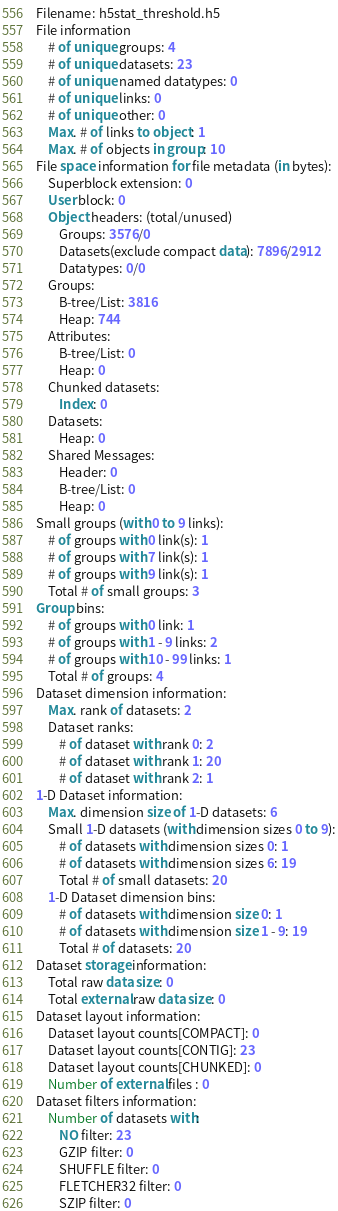<code> <loc_0><loc_0><loc_500><loc_500><_SQL_>Filename: h5stat_threshold.h5
File information
	# of unique groups: 4
	# of unique datasets: 23
	# of unique named datatypes: 0
	# of unique links: 0
	# of unique other: 0
	Max. # of links to object: 1
	Max. # of objects in group: 10
File space information for file metadata (in bytes):
	Superblock extension: 0
	User block: 0
	Object headers: (total/unused)
		Groups: 3576/0
		Datasets(exclude compact data): 7896/2912
		Datatypes: 0/0
	Groups:
		B-tree/List: 3816
		Heap: 744
	Attributes:
		B-tree/List: 0
		Heap: 0
	Chunked datasets:
		Index: 0
	Datasets:
		Heap: 0
	Shared Messages:
		Header: 0
		B-tree/List: 0
		Heap: 0
Small groups (with 0 to 9 links):
	# of groups with 0 link(s): 1
	# of groups with 7 link(s): 1
	# of groups with 9 link(s): 1
	Total # of small groups: 3
Group bins:
	# of groups with 0 link: 1
	# of groups with 1 - 9 links: 2
	# of groups with 10 - 99 links: 1
	Total # of groups: 4
Dataset dimension information:
	Max. rank of datasets: 2
	Dataset ranks:
		# of dataset with rank 0: 2
		# of dataset with rank 1: 20
		# of dataset with rank 2: 1
1-D Dataset information:
	Max. dimension size of 1-D datasets: 6
	Small 1-D datasets (with dimension sizes 0 to 9):
		# of datasets with dimension sizes 0: 1
		# of datasets with dimension sizes 6: 19
		Total # of small datasets: 20
	1-D Dataset dimension bins:
		# of datasets with dimension size 0: 1
		# of datasets with dimension size 1 - 9: 19
		Total # of datasets: 20
Dataset storage information:
	Total raw data size: 0
	Total external raw data size: 0
Dataset layout information:
	Dataset layout counts[COMPACT]: 0
	Dataset layout counts[CONTIG]: 23
	Dataset layout counts[CHUNKED]: 0
	Number of external files : 0
Dataset filters information:
	Number of datasets with:
		NO filter: 23
		GZIP filter: 0
		SHUFFLE filter: 0
		FLETCHER32 filter: 0
		SZIP filter: 0</code> 